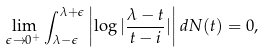<formula> <loc_0><loc_0><loc_500><loc_500>\lim _ { \epsilon \rightarrow 0 ^ { + } } \int _ { \lambda - \epsilon } ^ { \lambda + \epsilon } \left | \log | \frac { \lambda - t } { t - i } | \right | d N ( t ) = 0 ,</formula> 